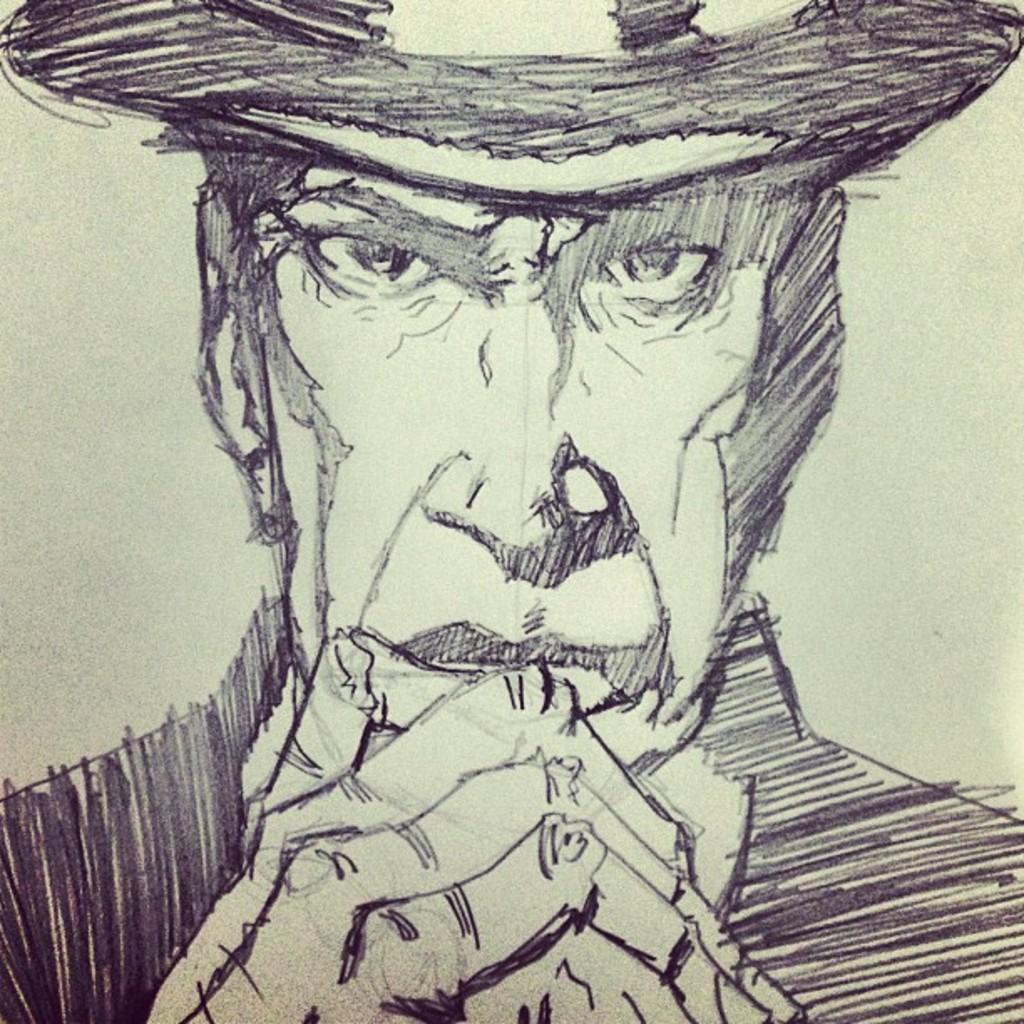Could you give a brief overview of what you see in this image? In this image we can see a drawing of a man wearing something on the head. 